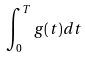Convert formula to latex. <formula><loc_0><loc_0><loc_500><loc_500>\int _ { 0 } ^ { T } g ( t ) d t</formula> 